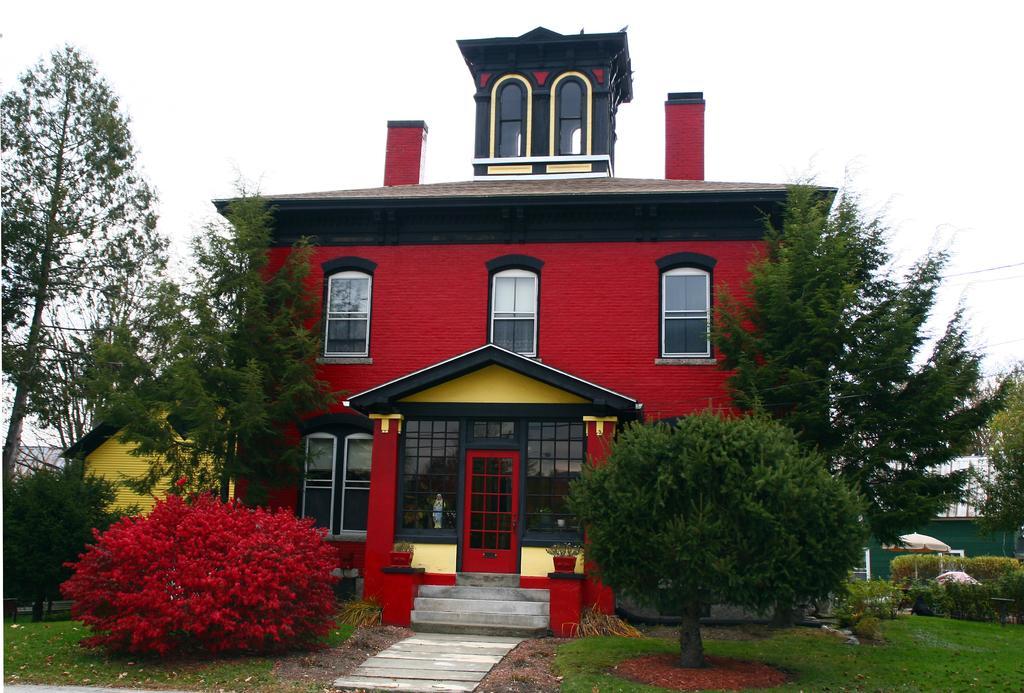In one or two sentences, can you explain what this image depicts? In this image there is a house in the middle and there are trees around it. In front of the house there are steps. On the left side there is a red colour plant. At the top there is sky. 